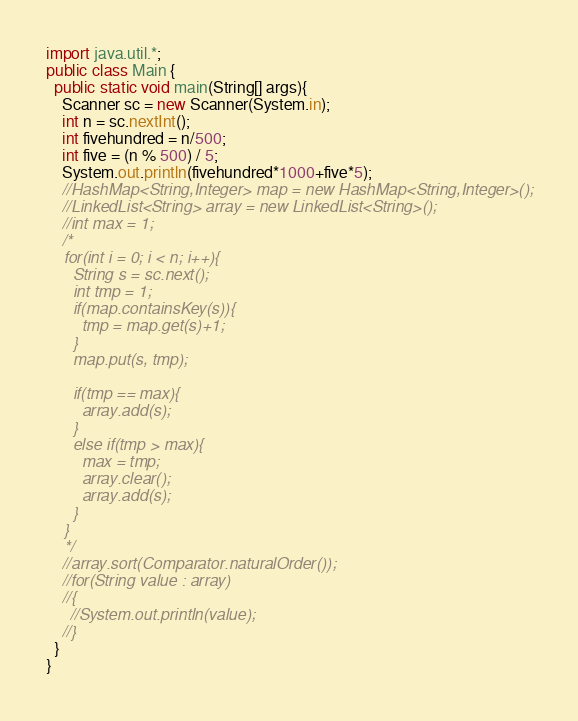<code> <loc_0><loc_0><loc_500><loc_500><_Java_>import java.util.*;
public class Main {
  public static void main(String[] args){
    Scanner sc = new Scanner(System.in);
	int n = sc.nextInt();
    int fivehundred = n/500;
    int five = (n % 500) / 5;
    System.out.println(fivehundred*1000+five*5);
    //HashMap<String,Integer> map = new HashMap<String,Integer>();
    //LinkedList<String> array = new LinkedList<String>();
    //int max = 1;
    /*
    for(int i = 0; i < n; i++){
      String s = sc.next();
      int tmp = 1;
      if(map.containsKey(s)){
        tmp = map.get(s)+1;
      }
      map.put(s, tmp);
      
      if(tmp == max){
        array.add(s);
      } 
      else if(tmp > max){
        max = tmp;
        array.clear();
        array.add(s);
      }
    }
    */
    //array.sort(Comparator.naturalOrder());
    //for(String value : array)
	//{
      //System.out.println(value);
	//}
  }
}</code> 